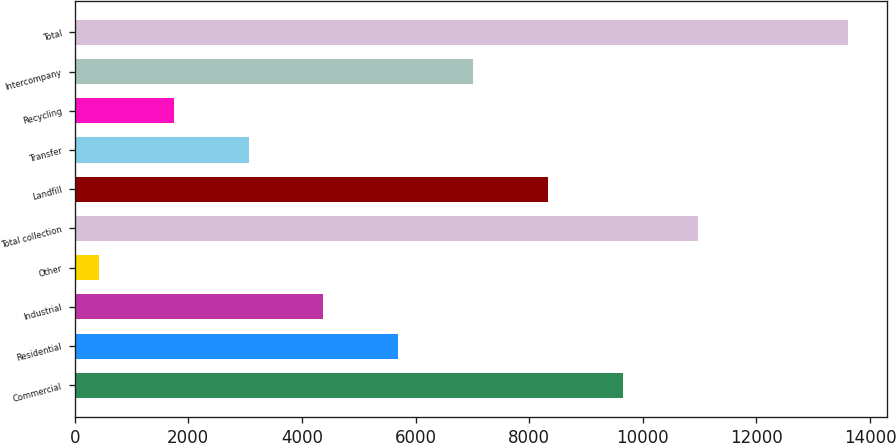Convert chart. <chart><loc_0><loc_0><loc_500><loc_500><bar_chart><fcel>Commercial<fcel>Residential<fcel>Industrial<fcel>Other<fcel>Total collection<fcel>Landfill<fcel>Transfer<fcel>Recycling<fcel>Intercompany<fcel>Total<nl><fcel>9653.2<fcel>5697.4<fcel>4378.8<fcel>423<fcel>10971.8<fcel>8334.6<fcel>3060.2<fcel>1741.6<fcel>7016<fcel>13609<nl></chart> 